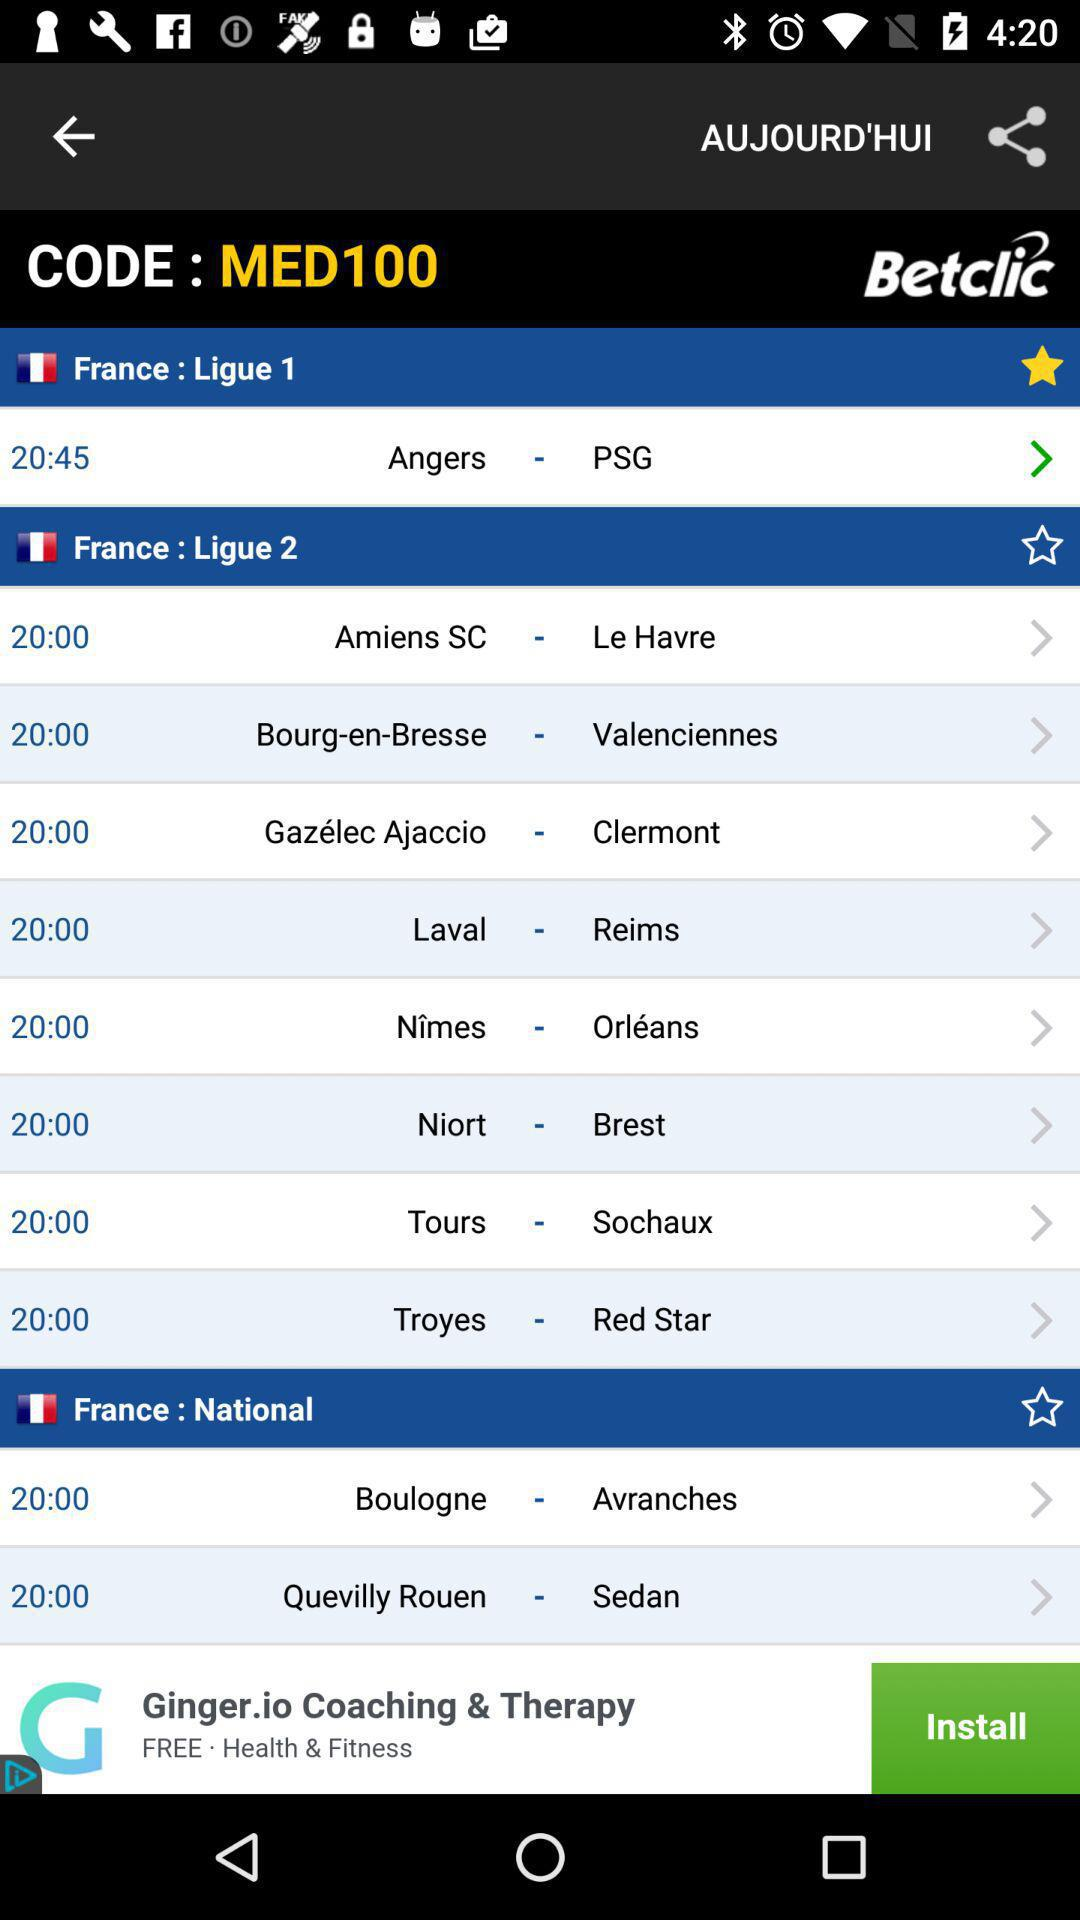What is the given time of the "Ligue 1" match in France? The given time of the "Ligue 1" match is 20:45. 